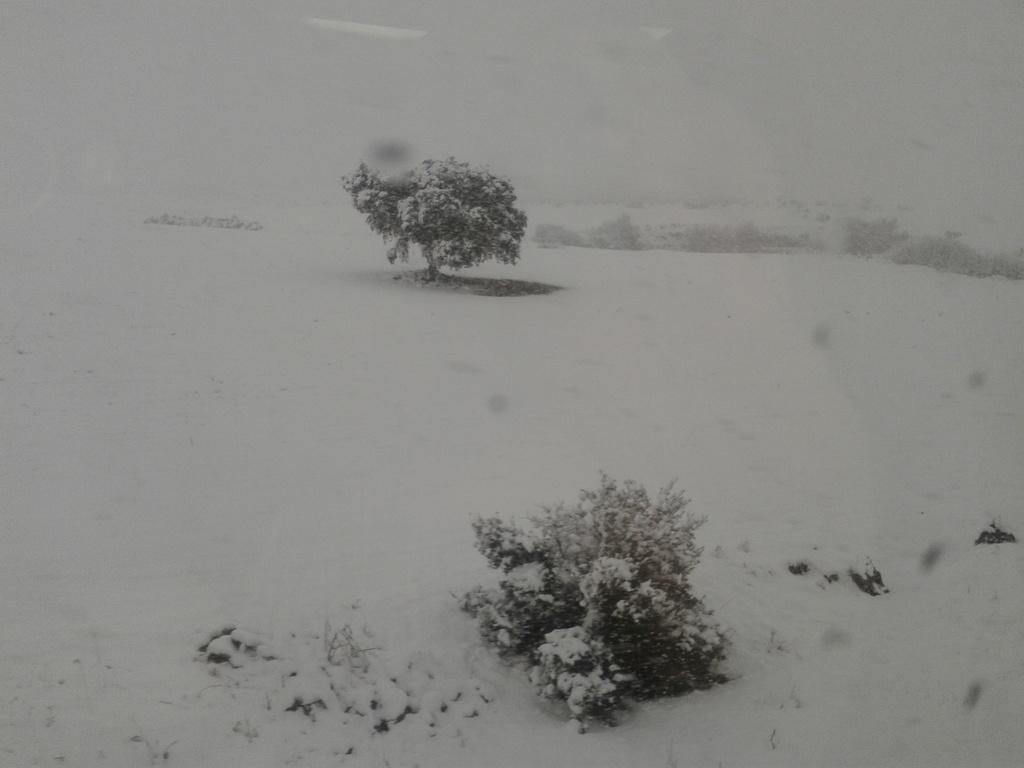What is the weather condition depicted in the image? There is snow in the image, indicating a cold and wintry scene. What type of vegetation can be seen in the image? There is a plant and a tree in the image. Can you describe the plant and the tree in the image? The facts provided do not give specific details about the plant and the tree, but they are both visible in the image. How many pigs are playing with the grandmother in the image? There are no pigs or grandmothers present in the image; it features snow, a plant, and a tree. What type of apparel is the grandmother wearing in the image? There is no grandmother or any apparel visible in the image. 